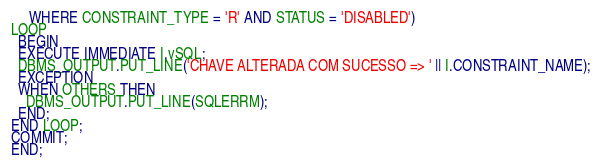<code> <loc_0><loc_0><loc_500><loc_500><_SQL_>     WHERE CONSTRAINT_TYPE = 'R' AND STATUS = 'DISABLED')
LOOP  
  BEGIN
  EXECUTE IMMEDIATE I.vSQL;  
  DBMS_OUTPUT.PUT_LINE('CHAVE ALTERADA COM SUCESSO => ' || I.CONSTRAINT_NAME);
  EXCEPTION
  WHEN OTHERS THEN
    DBMS_OUTPUT.PUT_LINE(SQLERRM);
  END;
END LOOP;
COMMIT;
END;</code> 